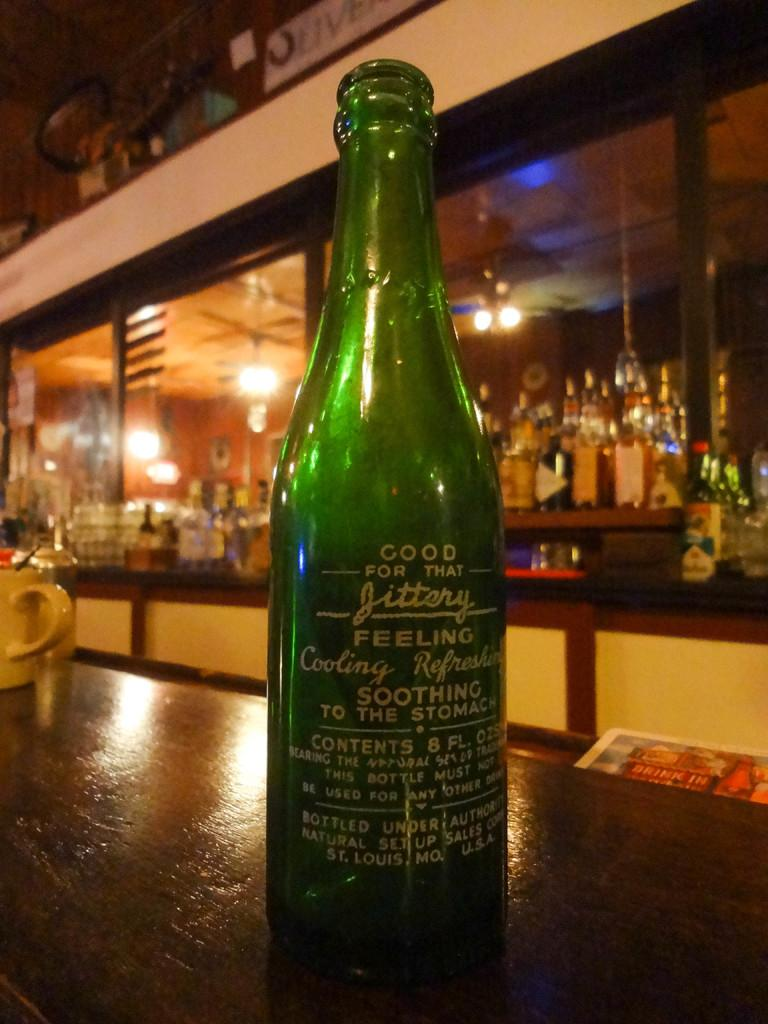<image>
Relay a brief, clear account of the picture shown. A green bottle that advertisises that it is "good for that jittery feeling". 